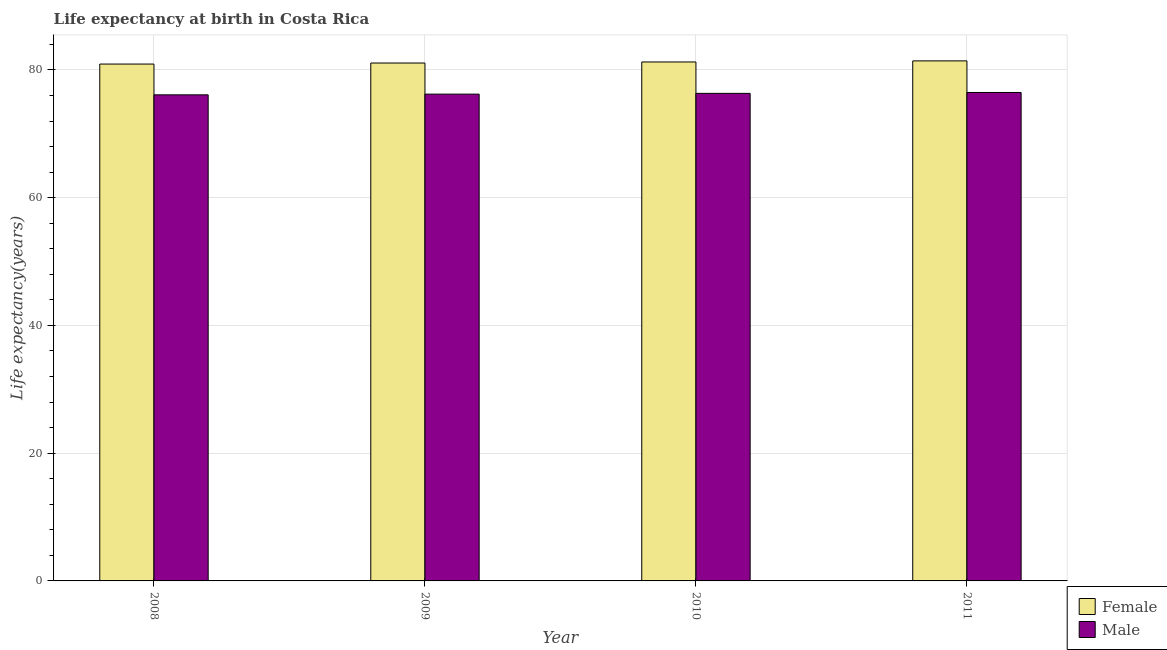How many different coloured bars are there?
Offer a very short reply. 2. How many bars are there on the 2nd tick from the right?
Give a very brief answer. 2. What is the label of the 1st group of bars from the left?
Give a very brief answer. 2008. In how many cases, is the number of bars for a given year not equal to the number of legend labels?
Provide a succinct answer. 0. What is the life expectancy(male) in 2009?
Provide a short and direct response. 76.22. Across all years, what is the maximum life expectancy(male)?
Your response must be concise. 76.48. Across all years, what is the minimum life expectancy(male)?
Offer a terse response. 76.11. In which year was the life expectancy(male) minimum?
Your answer should be very brief. 2008. What is the total life expectancy(female) in the graph?
Provide a short and direct response. 324.69. What is the difference between the life expectancy(male) in 2008 and that in 2009?
Ensure brevity in your answer.  -0.11. What is the difference between the life expectancy(female) in 2008 and the life expectancy(male) in 2010?
Offer a terse response. -0.33. What is the average life expectancy(male) per year?
Your response must be concise. 76.28. In the year 2008, what is the difference between the life expectancy(male) and life expectancy(female)?
Offer a very short reply. 0. What is the ratio of the life expectancy(male) in 2010 to that in 2011?
Offer a very short reply. 1. Is the life expectancy(male) in 2008 less than that in 2010?
Your answer should be very brief. Yes. What is the difference between the highest and the second highest life expectancy(female)?
Offer a terse response. 0.17. What is the difference between the highest and the lowest life expectancy(female)?
Make the answer very short. 0.5. Are all the bars in the graph horizontal?
Ensure brevity in your answer.  No. Are the values on the major ticks of Y-axis written in scientific E-notation?
Offer a very short reply. No. Does the graph contain grids?
Your answer should be very brief. Yes. What is the title of the graph?
Provide a succinct answer. Life expectancy at birth in Costa Rica. Does "Non-residents" appear as one of the legend labels in the graph?
Provide a succinct answer. No. What is the label or title of the X-axis?
Provide a short and direct response. Year. What is the label or title of the Y-axis?
Ensure brevity in your answer.  Life expectancy(years). What is the Life expectancy(years) in Female in 2008?
Offer a terse response. 80.93. What is the Life expectancy(years) of Male in 2008?
Your response must be concise. 76.11. What is the Life expectancy(years) of Female in 2009?
Keep it short and to the point. 81.09. What is the Life expectancy(years) in Male in 2009?
Offer a very short reply. 76.22. What is the Life expectancy(years) in Female in 2010?
Ensure brevity in your answer.  81.25. What is the Life expectancy(years) of Male in 2010?
Give a very brief answer. 76.34. What is the Life expectancy(years) in Female in 2011?
Your response must be concise. 81.42. What is the Life expectancy(years) in Male in 2011?
Provide a succinct answer. 76.48. Across all years, what is the maximum Life expectancy(years) in Female?
Your answer should be compact. 81.42. Across all years, what is the maximum Life expectancy(years) of Male?
Your answer should be compact. 76.48. Across all years, what is the minimum Life expectancy(years) in Female?
Provide a succinct answer. 80.93. Across all years, what is the minimum Life expectancy(years) of Male?
Your response must be concise. 76.11. What is the total Life expectancy(years) in Female in the graph?
Offer a very short reply. 324.69. What is the total Life expectancy(years) in Male in the graph?
Offer a very short reply. 305.14. What is the difference between the Life expectancy(years) in Female in 2008 and that in 2009?
Make the answer very short. -0.16. What is the difference between the Life expectancy(years) in Male in 2008 and that in 2009?
Offer a very short reply. -0.11. What is the difference between the Life expectancy(years) of Female in 2008 and that in 2010?
Ensure brevity in your answer.  -0.33. What is the difference between the Life expectancy(years) in Male in 2008 and that in 2010?
Offer a terse response. -0.23. What is the difference between the Life expectancy(years) in Female in 2008 and that in 2011?
Give a very brief answer. -0.5. What is the difference between the Life expectancy(years) in Male in 2008 and that in 2011?
Give a very brief answer. -0.37. What is the difference between the Life expectancy(years) of Female in 2009 and that in 2010?
Your answer should be very brief. -0.17. What is the difference between the Life expectancy(years) of Male in 2009 and that in 2010?
Offer a terse response. -0.12. What is the difference between the Life expectancy(years) of Female in 2009 and that in 2011?
Your answer should be compact. -0.34. What is the difference between the Life expectancy(years) in Male in 2009 and that in 2011?
Keep it short and to the point. -0.26. What is the difference between the Life expectancy(years) of Female in 2010 and that in 2011?
Your response must be concise. -0.17. What is the difference between the Life expectancy(years) of Male in 2010 and that in 2011?
Offer a terse response. -0.14. What is the difference between the Life expectancy(years) of Female in 2008 and the Life expectancy(years) of Male in 2009?
Your response must be concise. 4.71. What is the difference between the Life expectancy(years) of Female in 2008 and the Life expectancy(years) of Male in 2010?
Your answer should be very brief. 4.59. What is the difference between the Life expectancy(years) in Female in 2008 and the Life expectancy(years) in Male in 2011?
Your answer should be very brief. 4.45. What is the difference between the Life expectancy(years) in Female in 2009 and the Life expectancy(years) in Male in 2010?
Your answer should be compact. 4.75. What is the difference between the Life expectancy(years) in Female in 2009 and the Life expectancy(years) in Male in 2011?
Provide a short and direct response. 4.61. What is the difference between the Life expectancy(years) of Female in 2010 and the Life expectancy(years) of Male in 2011?
Your answer should be very brief. 4.78. What is the average Life expectancy(years) in Female per year?
Give a very brief answer. 81.17. What is the average Life expectancy(years) in Male per year?
Your response must be concise. 76.28. In the year 2008, what is the difference between the Life expectancy(years) in Female and Life expectancy(years) in Male?
Your answer should be very brief. 4.82. In the year 2009, what is the difference between the Life expectancy(years) of Female and Life expectancy(years) of Male?
Your answer should be very brief. 4.87. In the year 2010, what is the difference between the Life expectancy(years) in Female and Life expectancy(years) in Male?
Make the answer very short. 4.92. In the year 2011, what is the difference between the Life expectancy(years) of Female and Life expectancy(years) of Male?
Offer a very short reply. 4.95. What is the ratio of the Life expectancy(years) of Female in 2008 to that in 2009?
Provide a short and direct response. 1. What is the ratio of the Life expectancy(years) in Male in 2008 to that in 2009?
Offer a terse response. 1. What is the ratio of the Life expectancy(years) in Female in 2008 to that in 2010?
Your answer should be very brief. 1. What is the ratio of the Life expectancy(years) of Female in 2008 to that in 2011?
Ensure brevity in your answer.  0.99. What is the ratio of the Life expectancy(years) in Male in 2008 to that in 2011?
Keep it short and to the point. 1. What is the ratio of the Life expectancy(years) in Female in 2009 to that in 2010?
Provide a short and direct response. 1. What is the ratio of the Life expectancy(years) in Female in 2009 to that in 2011?
Your answer should be very brief. 1. What is the difference between the highest and the second highest Life expectancy(years) in Female?
Keep it short and to the point. 0.17. What is the difference between the highest and the second highest Life expectancy(years) in Male?
Ensure brevity in your answer.  0.14. What is the difference between the highest and the lowest Life expectancy(years) in Female?
Give a very brief answer. 0.5. What is the difference between the highest and the lowest Life expectancy(years) of Male?
Offer a very short reply. 0.37. 